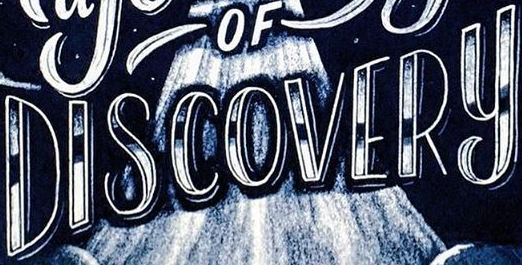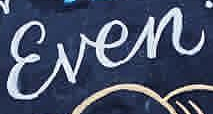What words are shown in these images in order, separated by a semicolon? DISCOVERY; Ɛven 